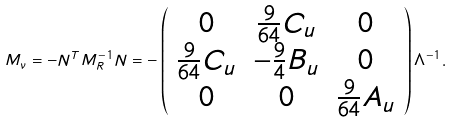<formula> <loc_0><loc_0><loc_500><loc_500>M _ { \nu } = - N ^ { T } M _ { R } ^ { - 1 } N = - \left ( \begin{array} { c c c } 0 & \frac { 9 } { 6 4 } C _ { u } & 0 \\ \frac { 9 } { 6 4 } C _ { u } & - \frac { 9 } { 4 } B _ { u } & 0 \\ 0 & 0 & \frac { 9 } { 6 4 } A _ { u } \end{array} \right ) \Lambda ^ { - 1 } .</formula> 